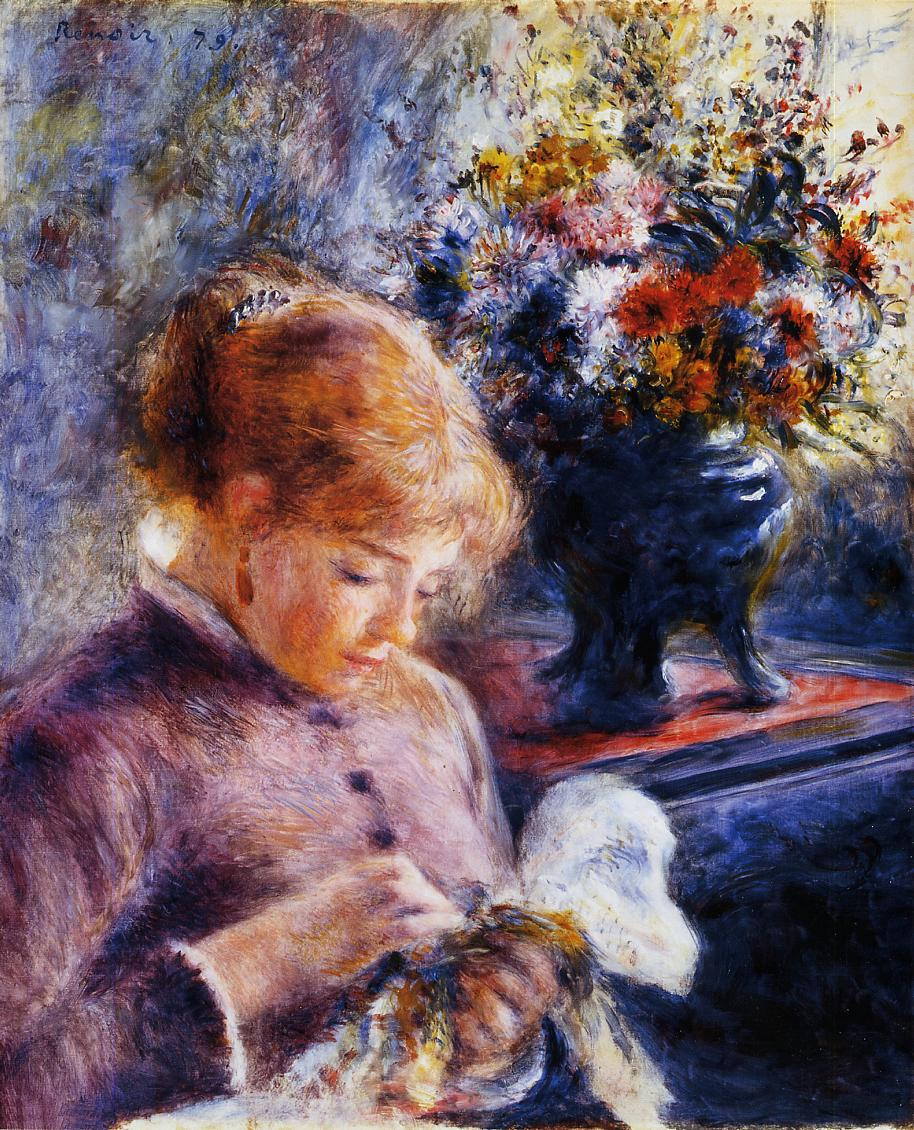Can you describe the emotions conveyed in this painting? The painting exudes a sense of tranquility and contemplation. The young woman, engrossed in her needlework, appears calm and focused, suggesting a quiet moment of introspection or meditation. The gentle and soft colors used in her dress and surroundings contribute to a peaceful ambiance, while the vibrant flowers on the table add a touch of liveliness and joy to the scene. Overall, the emotions conveyed are a blend of serenity, contentment, and the simple pleasure derived from a moment of concentration on a beloved task. 